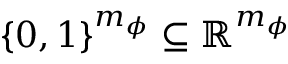<formula> <loc_0><loc_0><loc_500><loc_500>\{ 0 , 1 \} ^ { m _ { \phi } } \subseteq \mathbb { R } ^ { m _ { \phi } }</formula> 